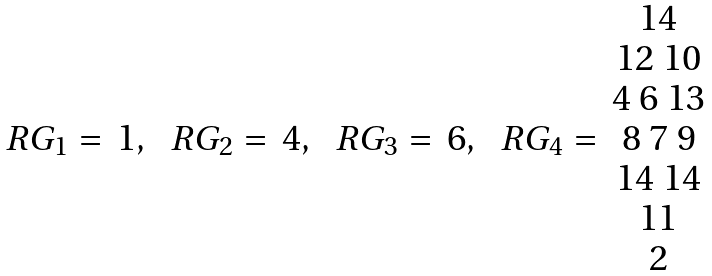Convert formula to latex. <formula><loc_0><loc_0><loc_500><loc_500>\begin{array} { c c } R G _ { 1 } = & 1 , \\ \end{array} \ \begin{array} { c c } R G _ { 2 } = & 4 , \\ \end{array} \ \begin{array} { c c } R G _ { 3 } = & 6 , \\ \end{array} \ \begin{array} { c c } & 1 4 \\ & 1 2 \ 1 0 \\ & 4 \ 6 \ 1 3 \\ R G _ { 4 } = & 8 \ 7 \ 9 \\ & 1 4 \ 1 4 \\ & 1 1 \\ & 2 \\ \end{array}</formula> 